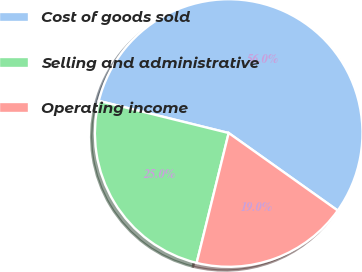<chart> <loc_0><loc_0><loc_500><loc_500><pie_chart><fcel>Cost of goods sold<fcel>Selling and administrative<fcel>Operating income<nl><fcel>55.97%<fcel>25.01%<fcel>19.01%<nl></chart> 